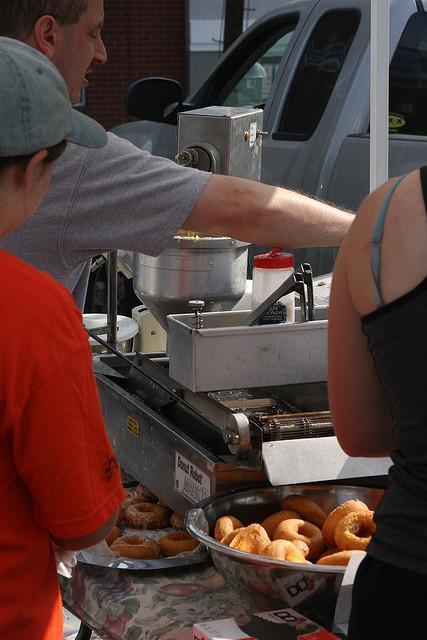Is the given caption "The truck is far from the bowl." fitting for the image?
Answer yes or no. No. 